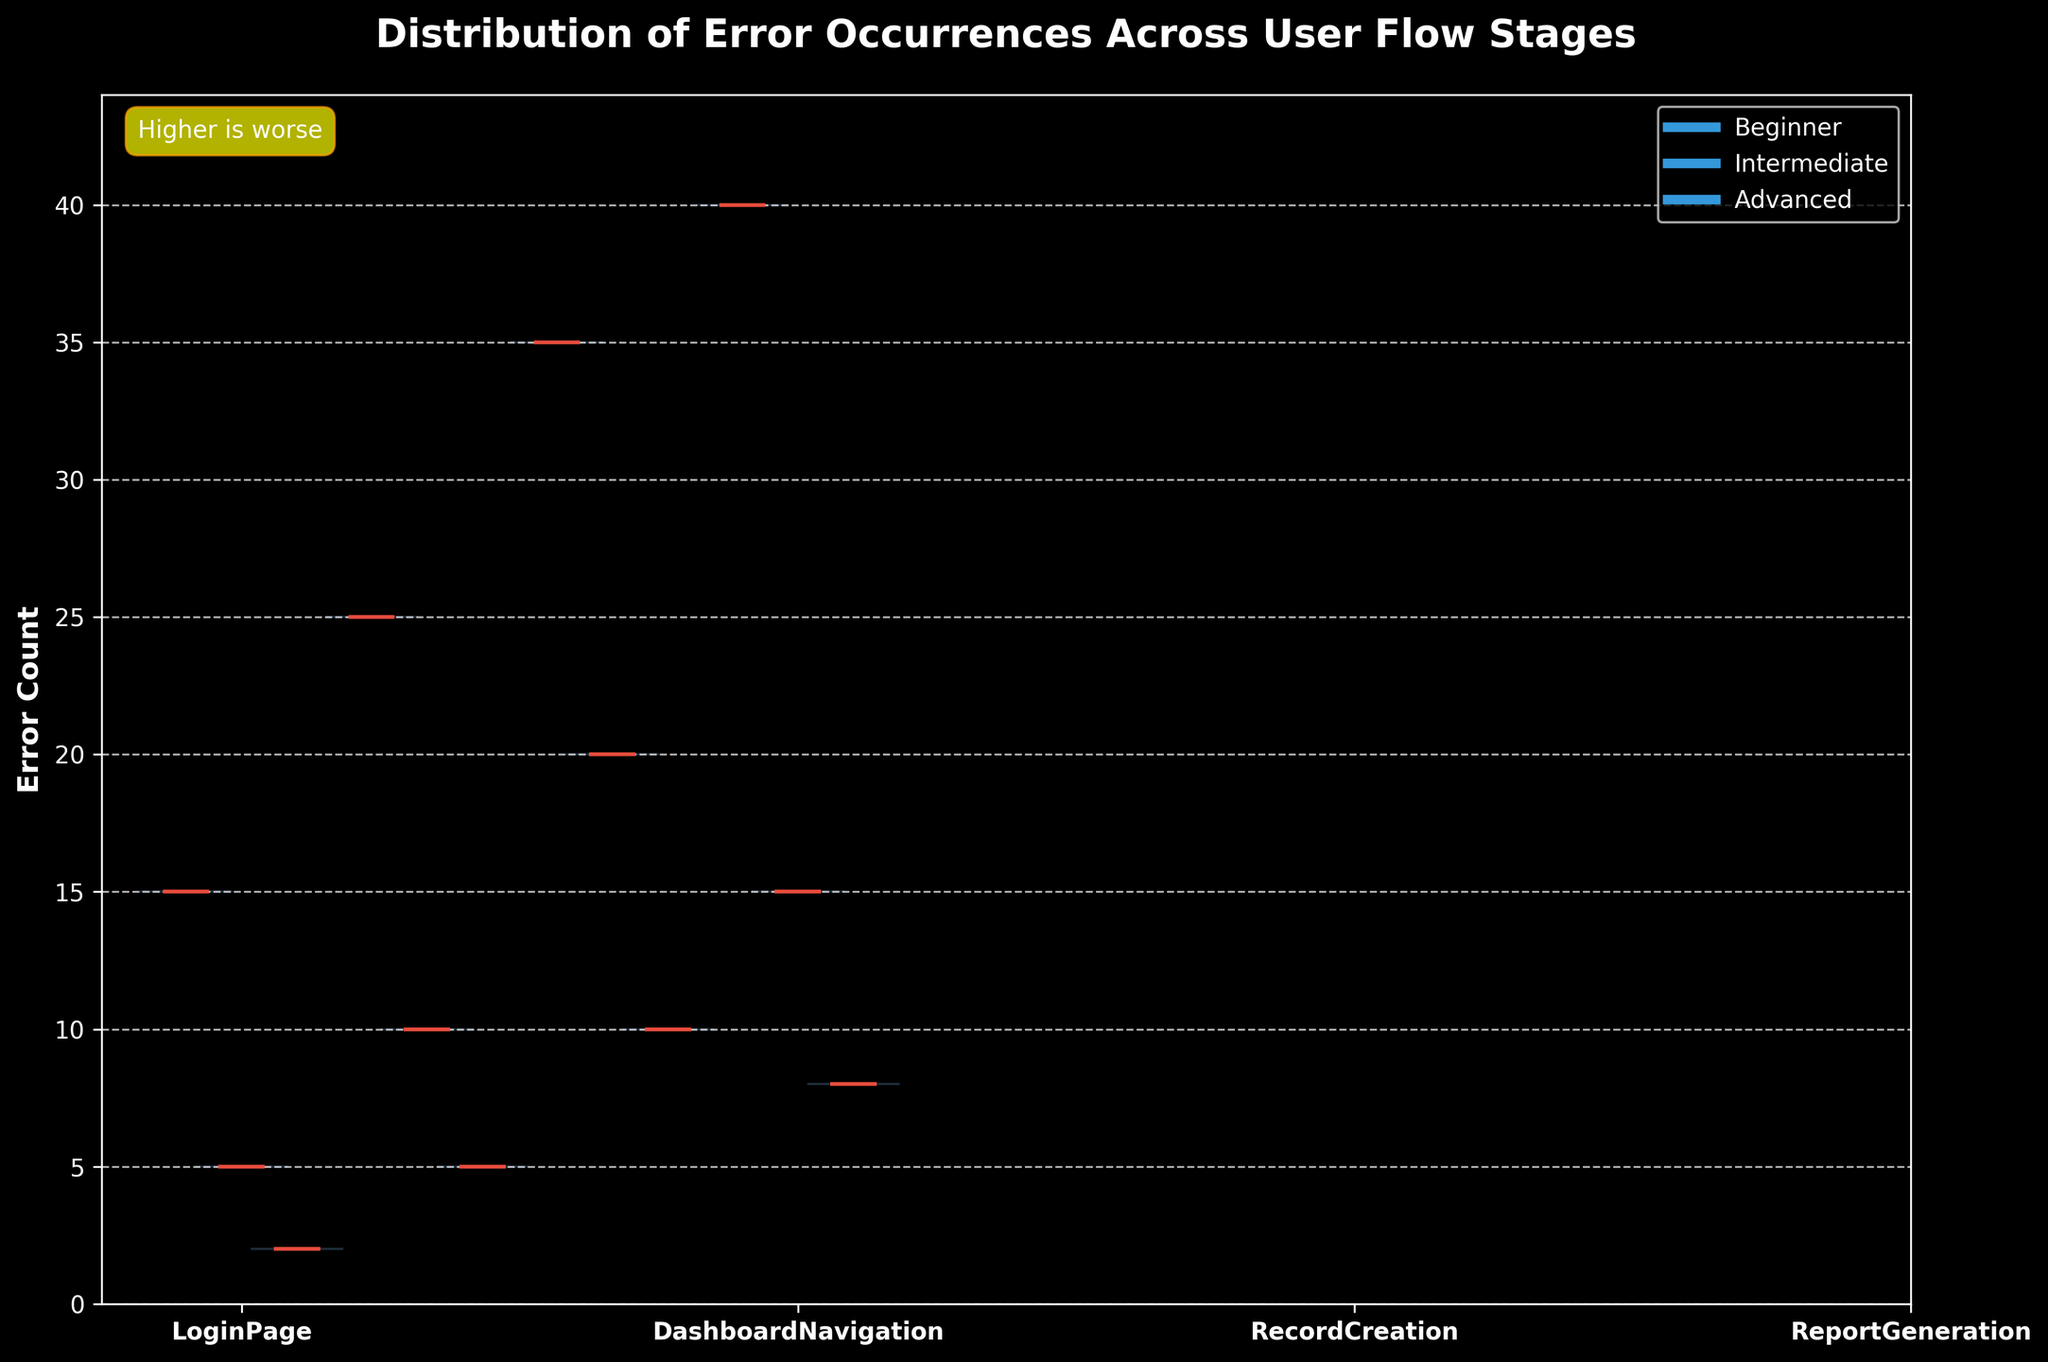What is the title of the chart? The title is displayed at the top of the chart. It reads "Distribution of Error Occurrences Across User Flow Stages".
Answer: Distribution of Error Occurrences Across User Flow Stages Which user experience level shows the highest error count in the ReportGeneration stage? The violin for the Beginner level in the ReportGeneration stage has the highest median error count as indicated by the thick red line within the blue shaded area. This is the highest among all user experience levels.
Answer: Beginner How do the error counts compare between Beginner and Advanced users in the RecordCreation stage? By examining the median lines in the blue shaded areas, we can see that the Beginner users have a higher median error count compared to the Advanced users in the RecordCreation stage.
Answer: Beginner users have a higher error count What is the trend observed across user experience levels from LoginPage to ReportGeneration? Moving from LoginPage to ReportGeneration, the error counts generally increase for all user experience levels. For Beginners, the increase is quite steep, while for Intermediate and Advanced users, the increase is more gradual.
Answer: Error counts increase from LoginPage to ReportGeneration for all levels Which stage has the least variation in error counts across all user experience levels? The LoginPage stage has the least variation in error counts across all user experience levels, as the violins are narrower with closely packed median lines.
Answer: LoginPage What does the annotation 'Higher is worse' imply in the context of this chart? The annotation 'Higher is worse' indicates that higher error counts represent poorer performance. It is relevant to the y-axis, which measures the count of errors.
Answer: Higher error counts are worse Which user experience level shows the lowest median error count in the DashboardNavigation stage? The Advanced users show the lowest median error count in the DashboardNavigation stage, as indicated by the position of the thick red line in the blue shaded area.
Answer: Advanced What is the overall error count trend for Intermediate users across all stages? For Intermediate users, the error count shows a slight increase from LoginPage to DashboardNavigation, then a steeper increase in RecordCreation followed by a slight decrease in ReportGeneration.
Answer: Increase, increase, then decrease How does the distribution of errors for Advanced users in ReportGeneration compare to that of Intermediate users in RecordCreation? The violin for Advanced users in ReportGeneration shows a lower median error count and smaller spread compared to the violin for Intermediate users in RecordCreation, indicating fewer and less varied errors for Advanced users.
Answer: Advanced users in ReportGeneration have fewer errors 